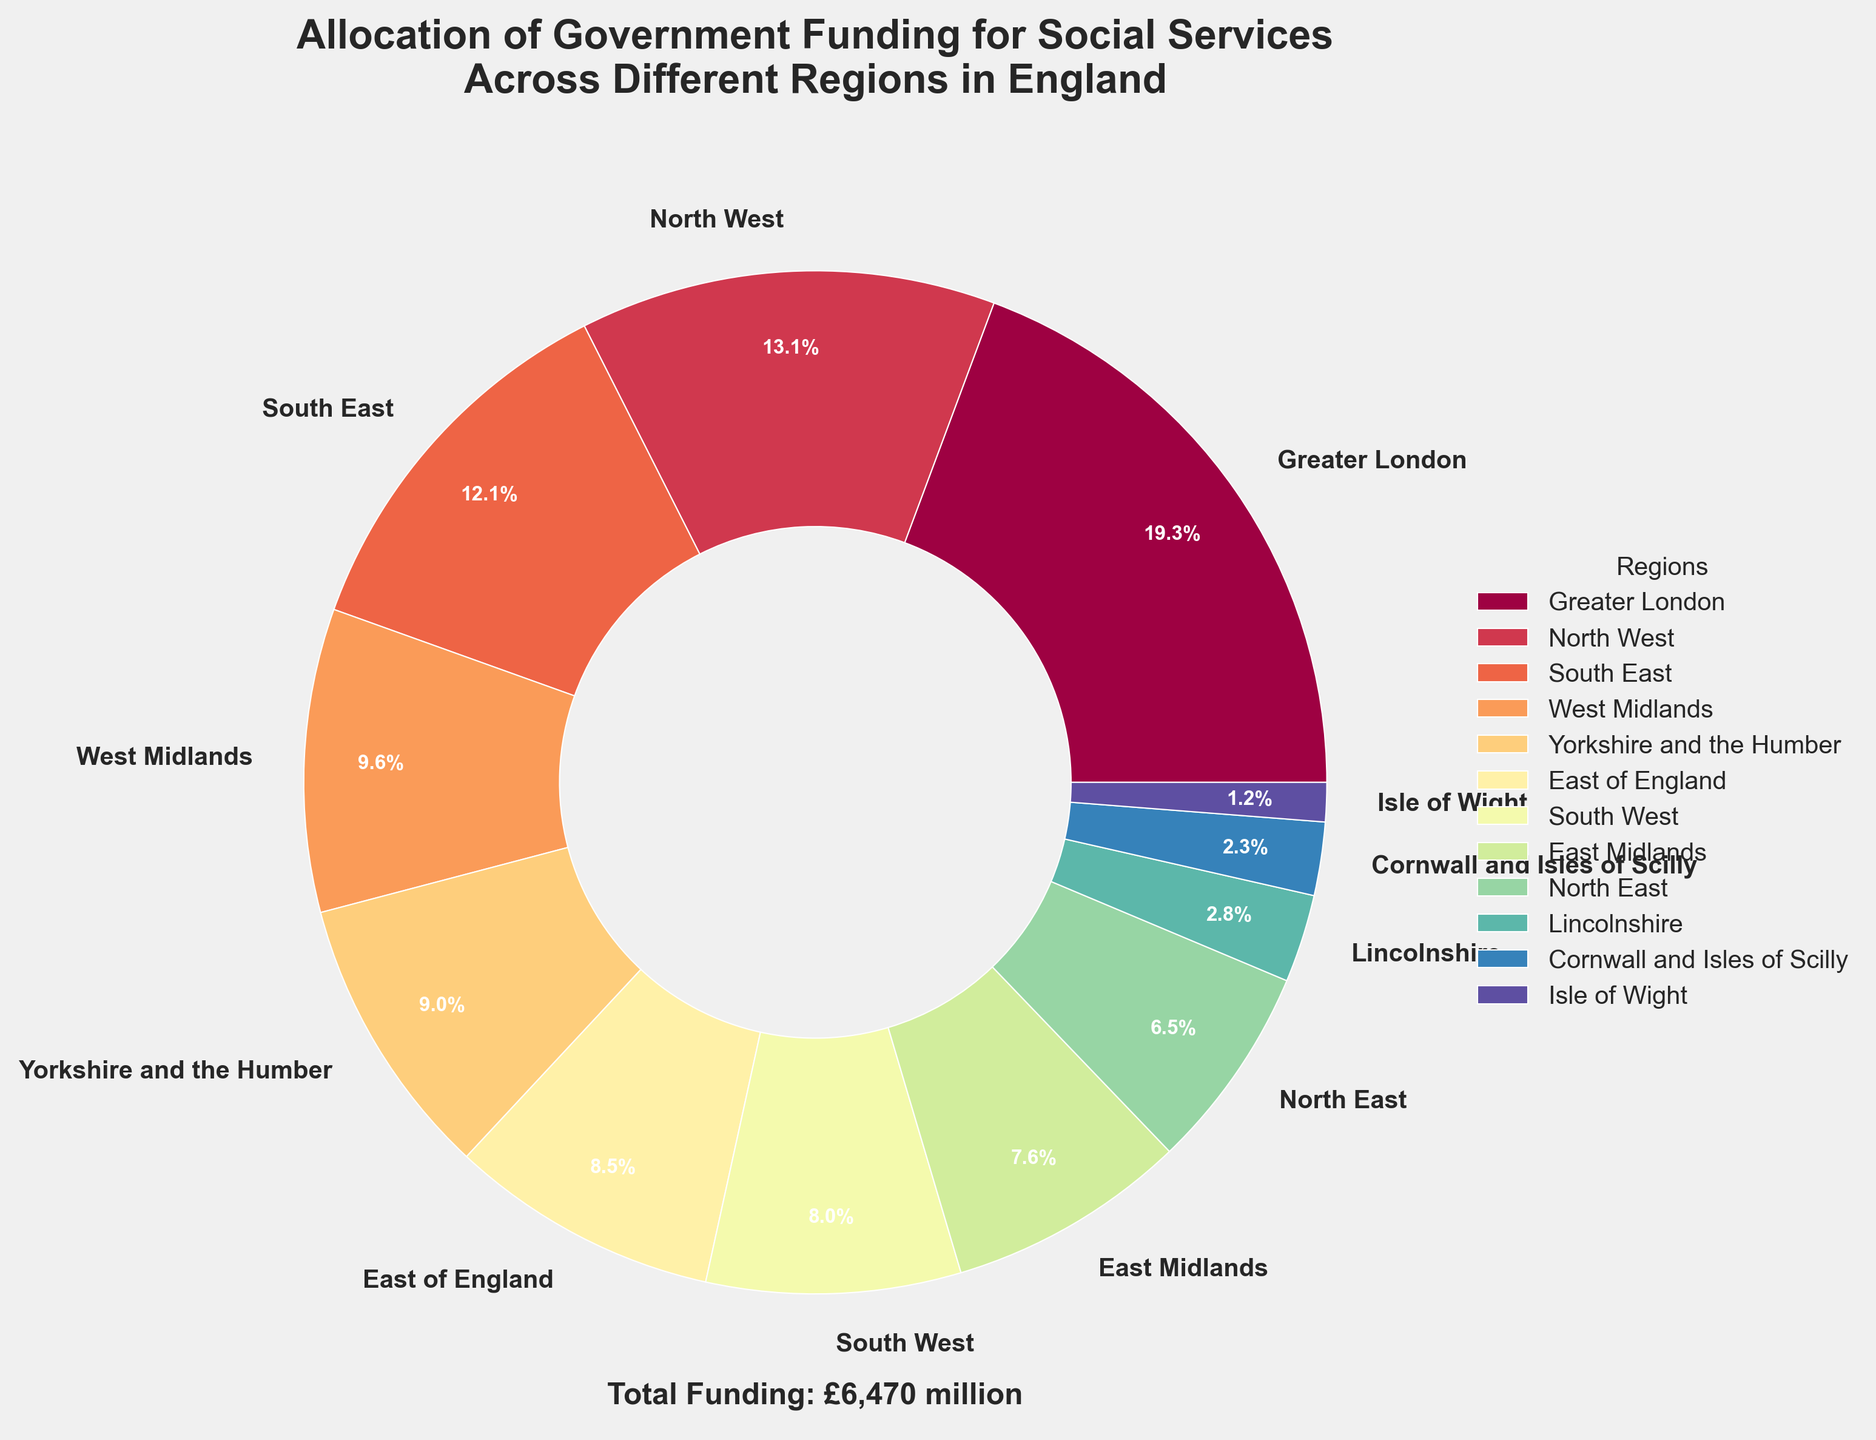Which region receives the highest allocation of government funding for social services? The region with the largest segment in the pie chart represents the highest allocation. The largest segment is named "Greater London"
Answer: Greater London What is the total funding allocation for the Greater London and South East regions combined? Greater London has £1250 million and South East has £780 million in funding. Summing these gives £1250 + £780 = £2030 million
Answer: £2030 million Which region has the smallest share of government funding for social services? The smallest segment in the pie chart represents the smallest share. This segment is labeled "Isle of Wight"
Answer: Isle of Wight How does the funding allocation for the North East compare to that for Yorkshire and the Humber? The North East has £420 million, while Yorkshire and the Humber has £580 million in government funding. Since £420 million < £580 million, the North East receives less funding than Yorkshire and the Humber
Answer: North East receives less funding Which regions, listed in the legend, have funding allocations below £500 million? From the pie chart labels and the legend, the regions with allocations below £500 million are East Midlands (£490 million), North East (£420 million), Lincolnshire (£180 million), Cornwall and Isles of Scilly (£150 million), and Isle of Wight (£80 million)
Answer: East Midlands, North East, Lincolnshire, Cornwall and Isles of Scilly, Isle of Wight What is the average funding allocation for the South West, East of England, and West Midlands regions? Funding allocations are: South West (£520 million), East of England (£550 million), West Midlands (£620 million). The sum is £520 + £550 + £620 = £1690 million. Dividing by 3, the average is £1690 / 3 ≈ £563.33 million
Answer: £563.33 million Which region receives more funding: North West or East of England? The funding for North West is £850 million and for East of England is £550 million. Since £850 million > £550 million, North West receives more funding
Answer: North West What is the total sum of allocations for regions with funding above £1000 million? Only Greater London has more than £1000 million, with £1250 million. The total sum is thus £1250 million
Answer: £1250 million What fraction of the total government funding does the West Midlands receive? The West Midlands receives £620 million. The total funding is £7260 million. The fraction is £620 million / £7260 million ≈ 0.085 or 8.5%
Answer: 8.5% How much more funding does Greater London receive compared to the North East? Greater London receives £1250 million while the North East gets £420 million. The difference is £1250 million - £420 million = £830 million
Answer: £830 million 